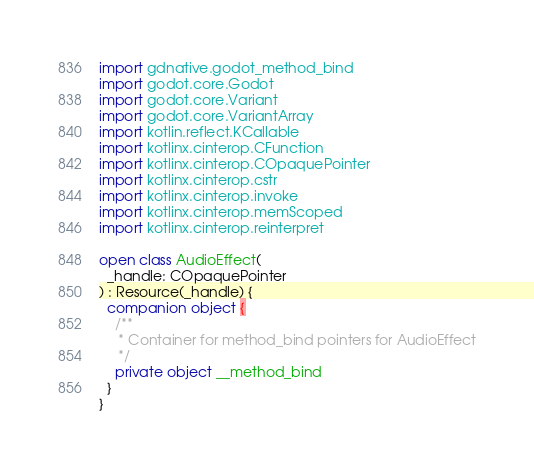<code> <loc_0><loc_0><loc_500><loc_500><_Kotlin_>import gdnative.godot_method_bind
import godot.core.Godot
import godot.core.Variant
import godot.core.VariantArray
import kotlin.reflect.KCallable
import kotlinx.cinterop.CFunction
import kotlinx.cinterop.COpaquePointer
import kotlinx.cinterop.cstr
import kotlinx.cinterop.invoke
import kotlinx.cinterop.memScoped
import kotlinx.cinterop.reinterpret

open class AudioEffect(
  _handle: COpaquePointer
) : Resource(_handle) {
  companion object {
    /**
     * Container for method_bind pointers for AudioEffect
     */
    private object __method_bind
  }
}
</code> 